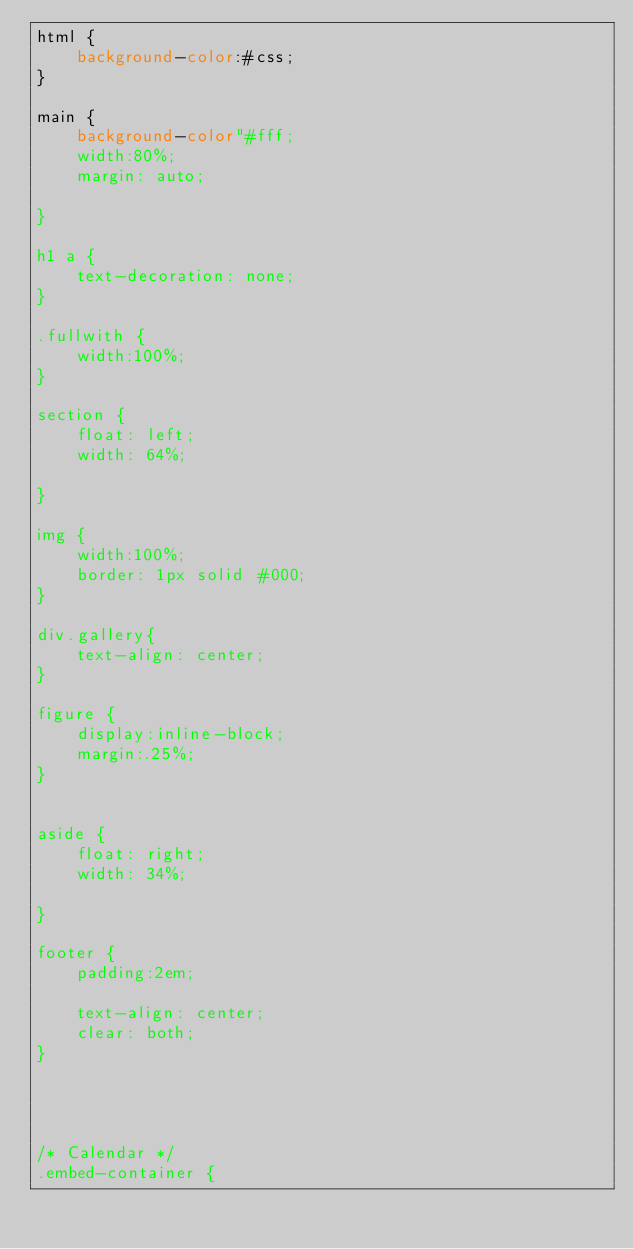Convert code to text. <code><loc_0><loc_0><loc_500><loc_500><_CSS_>html {
    background-color:#css;
}

main {
    background-color"#fff;
    width:80%;
    margin: auto;
    
}

h1 a {
    text-decoration: none;
}

.fullwith {
    width:100%;
}

section {
    float: left;
    width: 64%;
 
}

img {
    width:100%;
    border: 1px solid #000;
}

div.gallery{
    text-align: center;
}

figure {
    display:inline-block;
    margin:.25%;
}


aside {
    float: right;
    width: 34%;
   
}

footer {
    padding:2em; 

    text-align: center; 
    clear: both;
}




/* Calendar */
.embed-container {</code> 